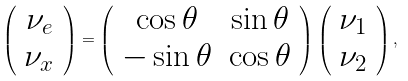<formula> <loc_0><loc_0><loc_500><loc_500>\left ( \begin{array} { c } \nu _ { e } \\ \nu _ { x } \end{array} \right ) = \left ( \begin{array} { c c } \cos \theta & \sin \theta \\ - \sin \theta & \cos \theta \end{array} \right ) \left ( \begin{array} { c } \nu _ { 1 } \\ \nu _ { 2 } \end{array} \right ) ,</formula> 